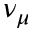Convert formula to latex. <formula><loc_0><loc_0><loc_500><loc_500>\nu _ { \mu }</formula> 